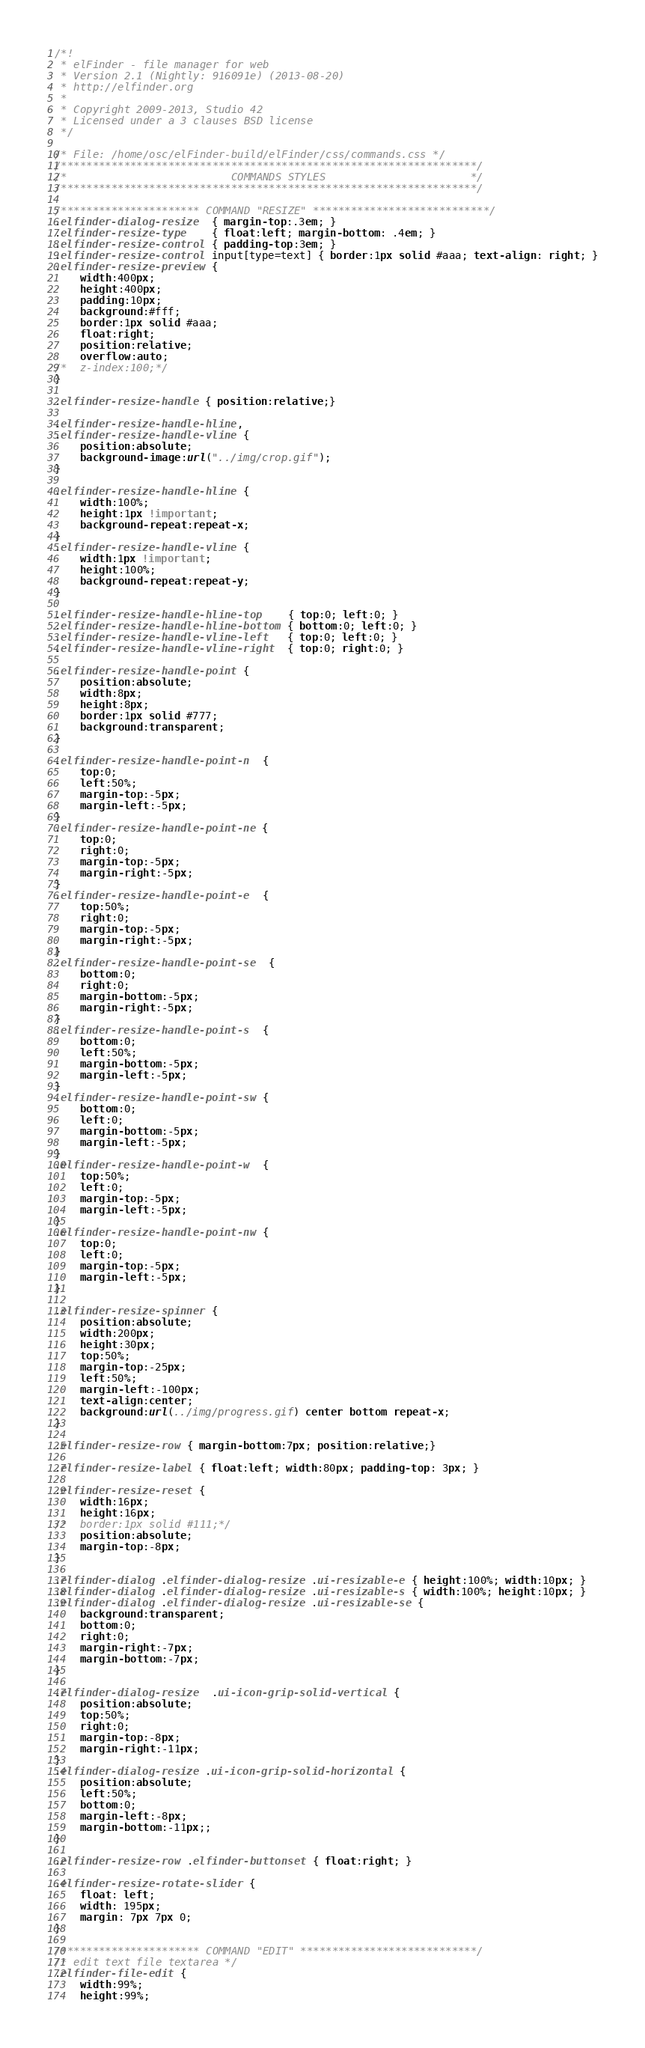<code> <loc_0><loc_0><loc_500><loc_500><_CSS_>/*!
 * elFinder - file manager for web
 * Version 2.1 (Nightly: 916091e) (2013-08-20)
 * http://elfinder.org
 * 
 * Copyright 2009-2013, Studio 42
 * Licensed under a 3 clauses BSD license
 */

/* File: /home/osc/elFinder-build/elFinder/css/commands.css */
/******************************************************************/
/*                          COMMANDS STYLES                       */
/******************************************************************/

/********************** COMMAND "RESIZE" ****************************/
.elfinder-dialog-resize  { margin-top:.3em; }
.elfinder-resize-type    { float:left; margin-bottom: .4em; }
.elfinder-resize-control { padding-top:3em; }
.elfinder-resize-control input[type=text] { border:1px solid #aaa; text-align: right; }
.elfinder-resize-preview {
	width:400px;
	height:400px;
	padding:10px;
	background:#fff;
	border:1px solid #aaa;
	float:right;
	position:relative;
	overflow:auto;
/*	z-index:100;*/
}

.elfinder-resize-handle { position:relative;}

.elfinder-resize-handle-hline,
.elfinder-resize-handle-vline {
	position:absolute;
	background-image:url("../img/crop.gif");
}

.elfinder-resize-handle-hline {
	width:100%;
	height:1px !important;
	background-repeat:repeat-x;
}
.elfinder-resize-handle-vline {
	width:1px !important;
	height:100%;
	background-repeat:repeat-y;
}

.elfinder-resize-handle-hline-top    { top:0; left:0; }
.elfinder-resize-handle-hline-bottom { bottom:0; left:0; }
.elfinder-resize-handle-vline-left   { top:0; left:0; }
.elfinder-resize-handle-vline-right  { top:0; right:0; }

.elfinder-resize-handle-point {
	position:absolute;
	width:8px;
	height:8px;
	border:1px solid #777;
	background:transparent;
}

.elfinder-resize-handle-point-n  {
	top:0;
	left:50%;
	margin-top:-5px;
	margin-left:-5px;
}
.elfinder-resize-handle-point-ne {
	top:0;
	right:0;
	margin-top:-5px;
	margin-right:-5px;
}
.elfinder-resize-handle-point-e  {
	top:50%;
	right:0;
	margin-top:-5px;
	margin-right:-5px;
}
.elfinder-resize-handle-point-se  {
	bottom:0;
	right:0;
	margin-bottom:-5px;
	margin-right:-5px;
}
.elfinder-resize-handle-point-s  {
	bottom:0;
	left:50%;
	margin-bottom:-5px;
	margin-left:-5px;
}
.elfinder-resize-handle-point-sw {
	bottom:0;
	left:0;
	margin-bottom:-5px;
	margin-left:-5px;
}
.elfinder-resize-handle-point-w  {
	top:50%;
	left:0;
	margin-top:-5px;
	margin-left:-5px;
}
.elfinder-resize-handle-point-nw {
	top:0;
	left:0;
	margin-top:-5px;
	margin-left:-5px;
}

.elfinder-resize-spinner {
	position:absolute;
	width:200px;
	height:30px;
	top:50%;
	margin-top:-25px;
	left:50%;
	margin-left:-100px;
	text-align:center;
	background:url(../img/progress.gif) center bottom repeat-x;
}

.elfinder-resize-row { margin-bottom:7px; position:relative;}

.elfinder-resize-label { float:left; width:80px; padding-top: 3px; }

.elfinder-resize-reset {
	width:16px;
	height:16px;
/*	border:1px solid #111;*/
	position:absolute;
	margin-top:-8px;
}

.elfinder-dialog .elfinder-dialog-resize .ui-resizable-e { height:100%; width:10px; }
.elfinder-dialog .elfinder-dialog-resize .ui-resizable-s { width:100%; height:10px; }
.elfinder-dialog .elfinder-dialog-resize .ui-resizable-se { 
	background:transparent; 
	bottom:0; 
	right:0; 
	margin-right:-7px;
	margin-bottom:-7px;
}

.elfinder-dialog-resize  .ui-icon-grip-solid-vertical {
	position:absolute;
	top:50%;
	right:0;
	margin-top:-8px;
	margin-right:-11px;
}
.elfinder-dialog-resize .ui-icon-grip-solid-horizontal {
	position:absolute;
	left:50%;
	bottom:0;
	margin-left:-8px;
	margin-bottom:-11px;;
}

.elfinder-resize-row .elfinder-buttonset { float:right; }

.elfinder-resize-rotate-slider {
	float: left;
	width: 195px;
	margin: 7px 7px 0;
}

/********************** COMMAND "EDIT" ****************************/
/* edit text file textarea */
.elfinder-file-edit {
	width:99%;
	height:99%;</code> 